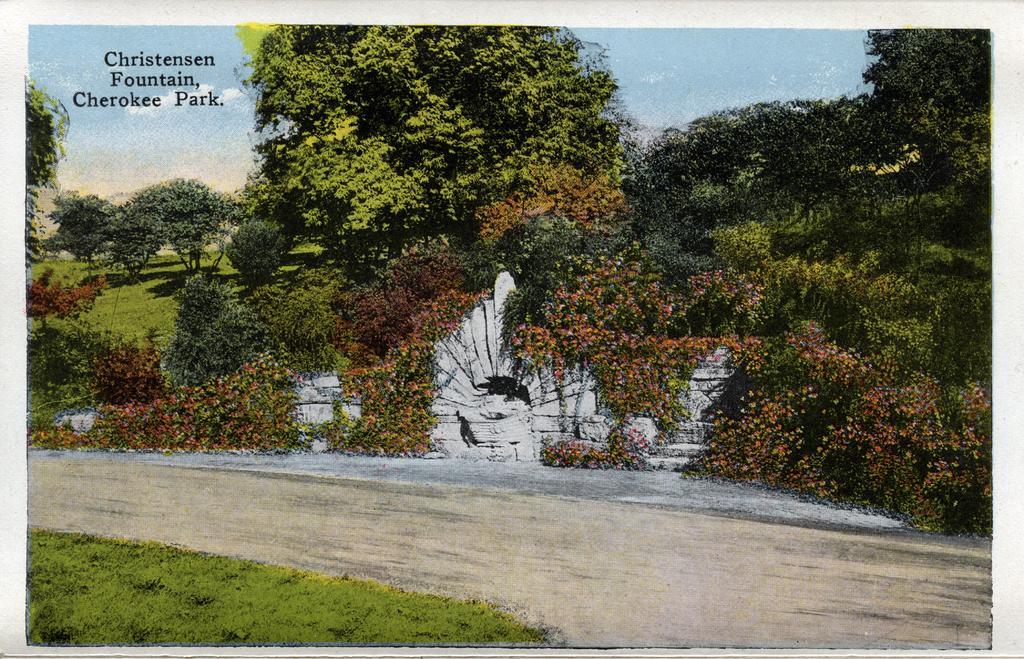How would you summarize this image in a sentence or two? In this picture there is a photograph of the park. In the front there are many trees and in the middle there is a small white color wall. 